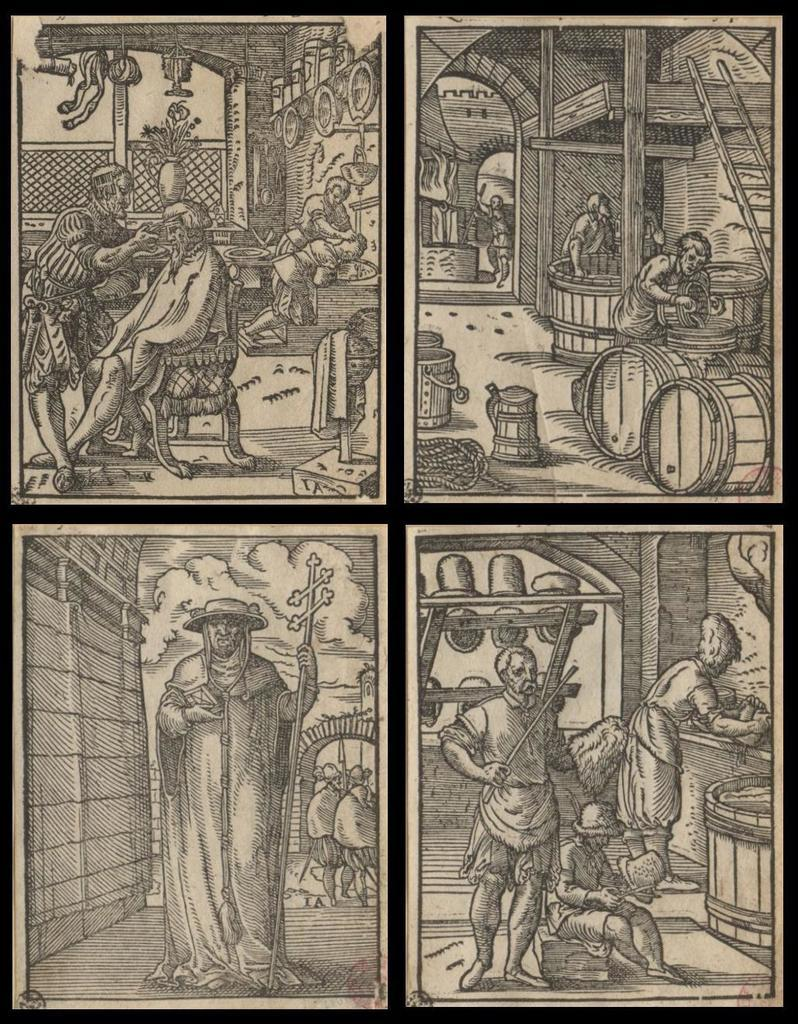What is the color scheme of the image? The image is black and white. What type of pictures can be seen in the image? There are collage pictures of drawings of a person in the image. Where is the aunt sitting in the image? There is no aunt present in the image; it only contains collage pictures of drawings of a person. What type of tree can be seen in the image? There is no tree present in the image; it is a black and white collage of drawings of a person. 